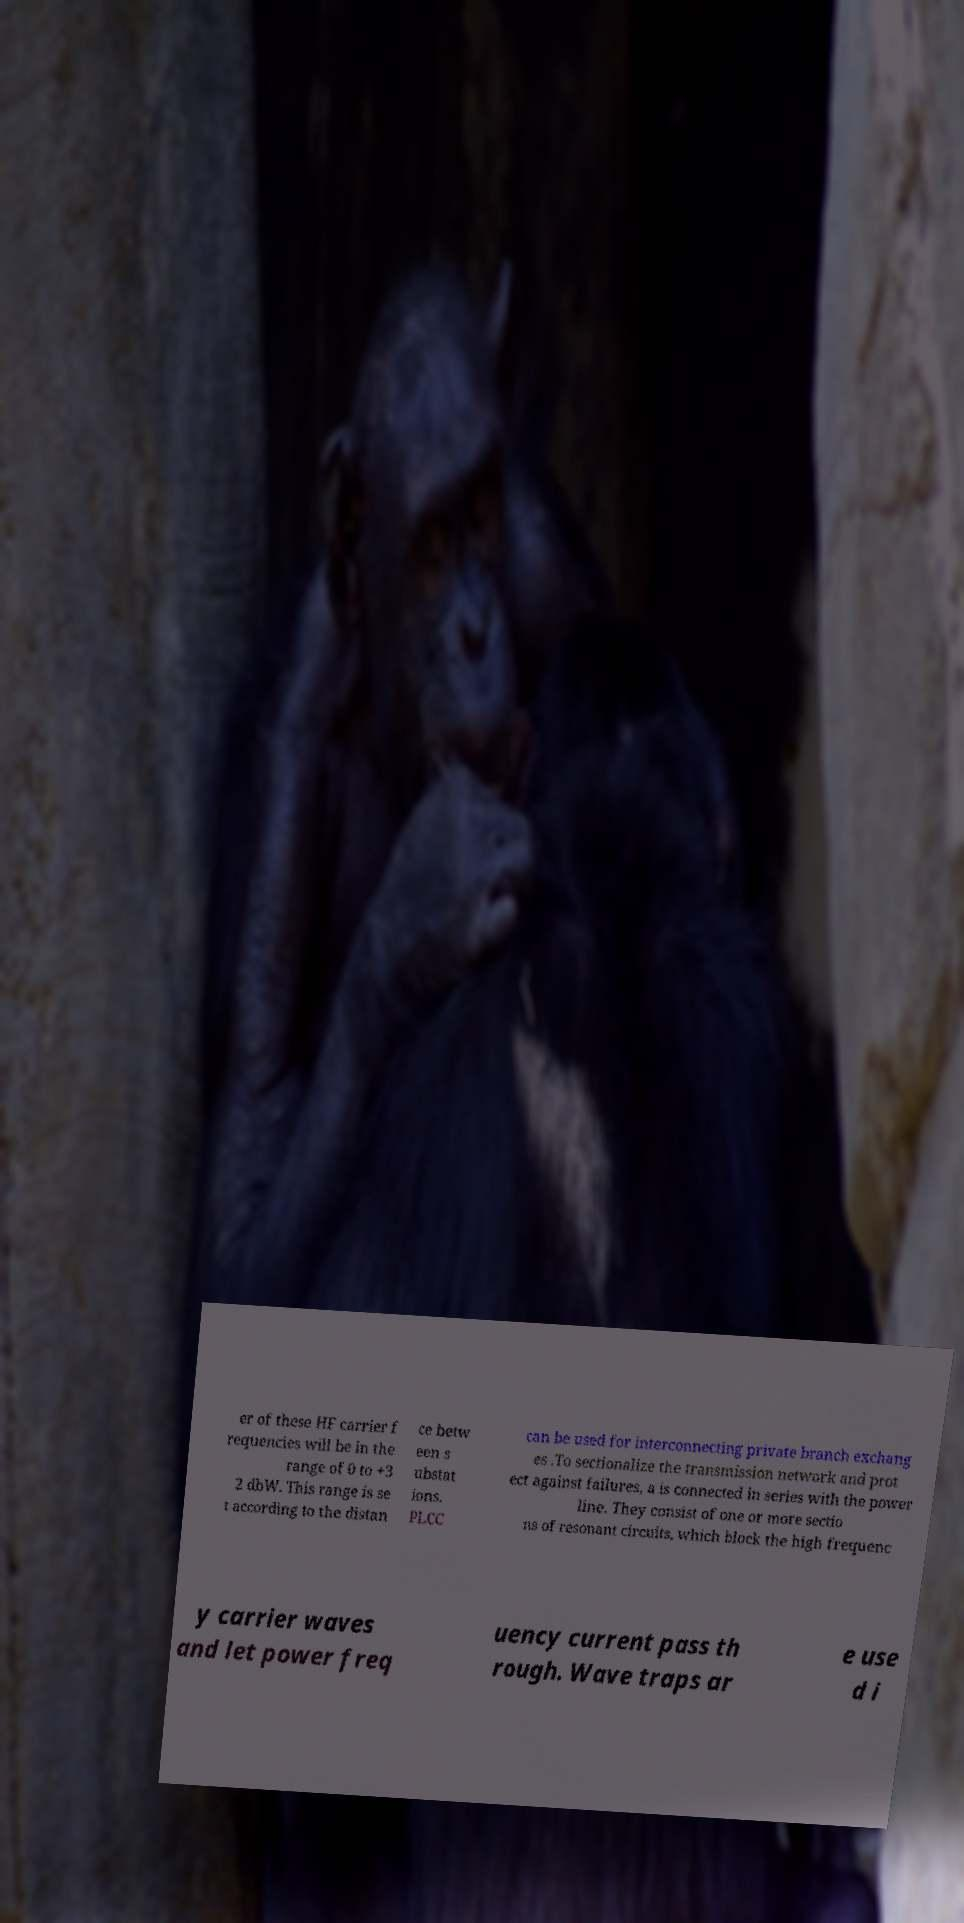Please read and relay the text visible in this image. What does it say? er of these HF carrier f requencies will be in the range of 0 to +3 2 dbW. This range is se t according to the distan ce betw een s ubstat ions. PLCC can be used for interconnecting private branch exchang es .To sectionalize the transmission network and prot ect against failures, a is connected in series with the power line. They consist of one or more sectio ns of resonant circuits, which block the high frequenc y carrier waves and let power freq uency current pass th rough. Wave traps ar e use d i 